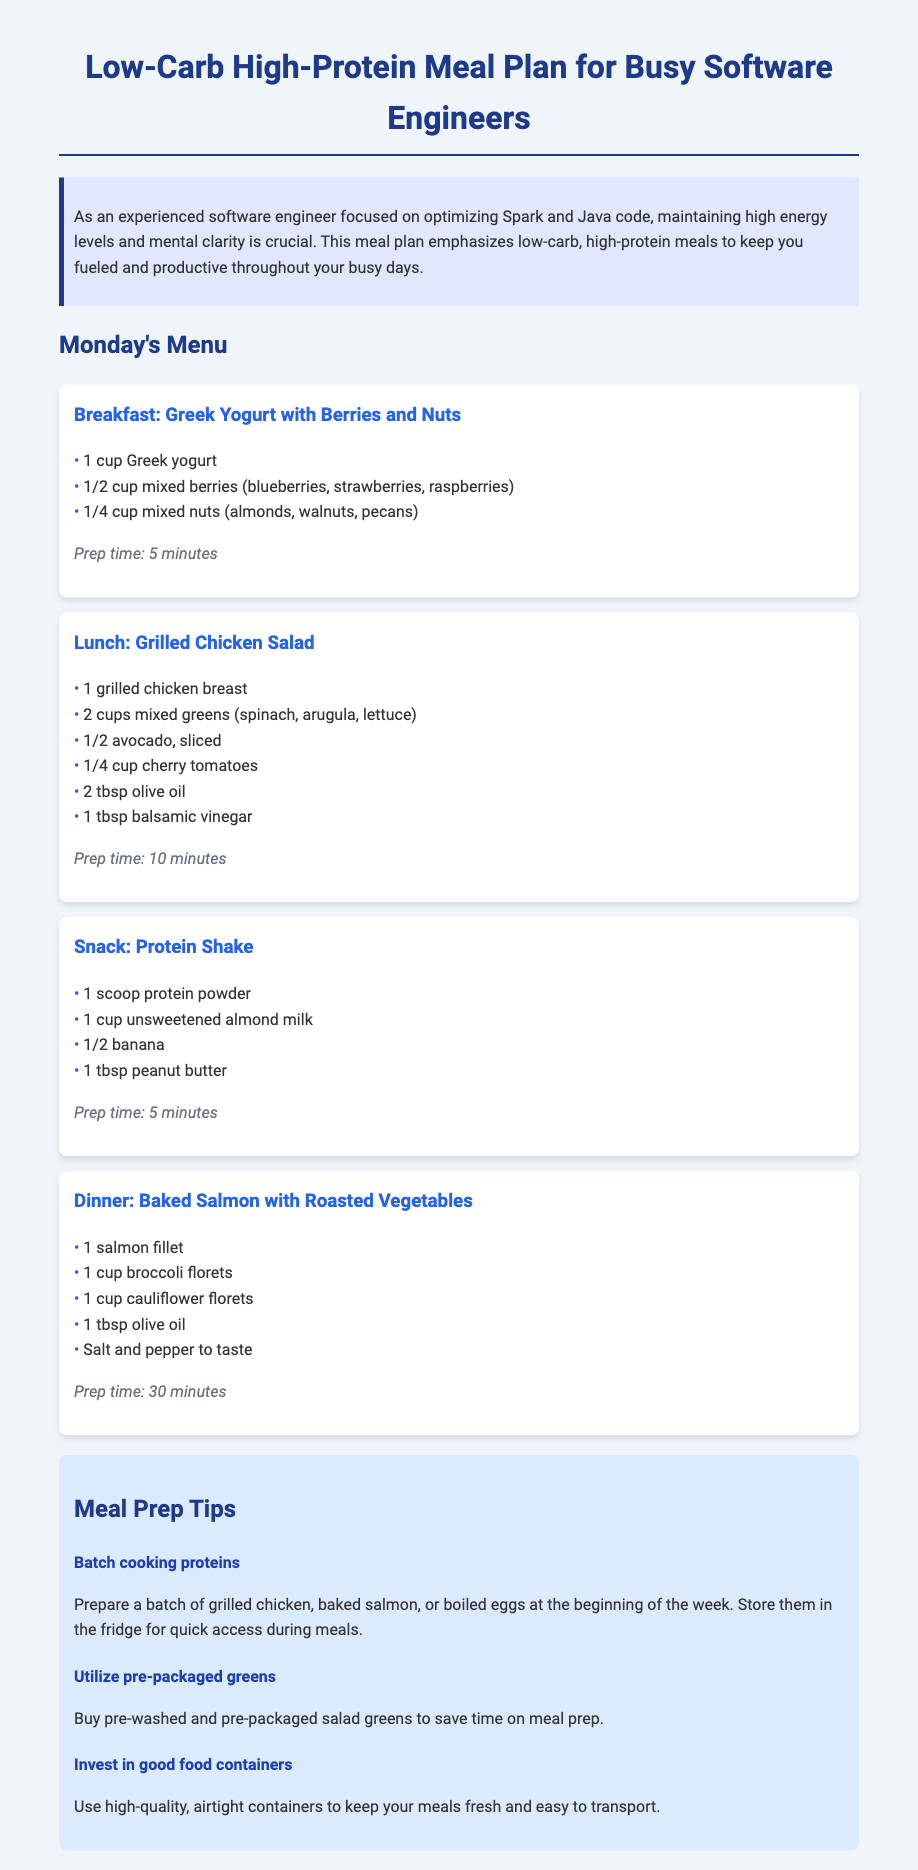What is the main focus of the meal plan? The meal plan emphasizes low-carb, high-protein meals to keep busy software engineers fueled and productive.
Answer: low-carb high-protein meals What is one of the ingredients in the breakfast? The breakfast includes Greek yogurt, mixed berries, and mixed nuts as ingredients.
Answer: Greek yogurt How long does it take to prepare the protein shake? The preparation time for the protein shake is mentioned in the document.
Answer: 5 minutes What type of salad is included in Monday's lunch? The type of salad specified for lunch includes certain greens.
Answer: Grilled Chicken Salad What is a tip mentioned for meal prep? The document lists several tips for meal prep that are beneficial for busy individuals.
Answer: Batch cooking proteins How many ingredients are listed for dinner? The dinner meal includes several specific ingredients detailed in the meal plan.
Answer: 5 ingredients What type of milk is used in the protein shake? The protein shake specifically includes a type of milk as one of its ingredients.
Answer: Unsweetened almond milk Which type of fish is featured in Monday's dinner? The document details a specific type of fish prepared for dinner.
Answer: Salmon 